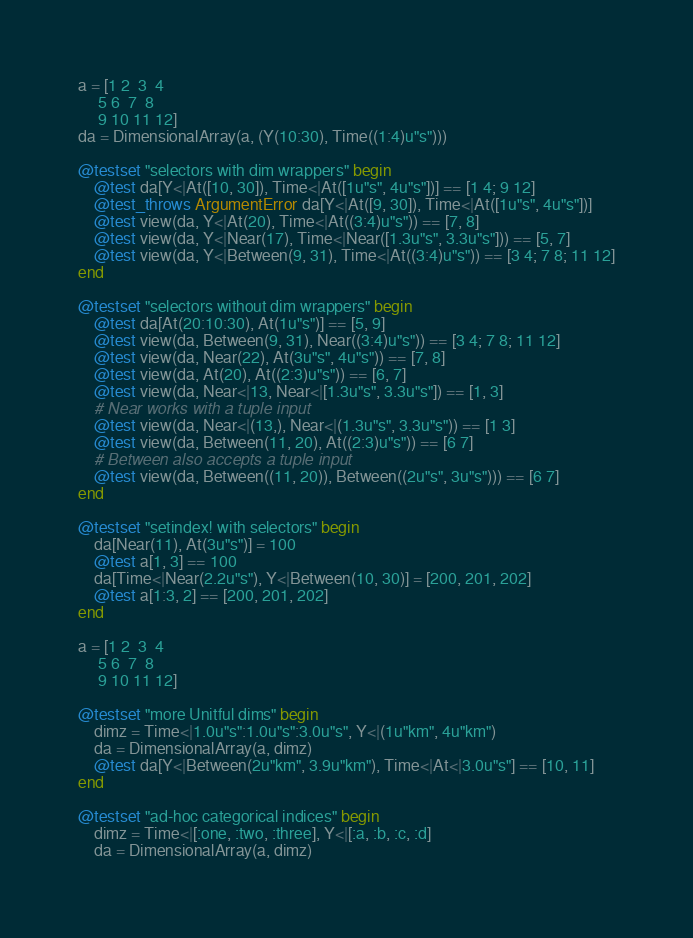Convert code to text. <code><loc_0><loc_0><loc_500><loc_500><_Julia_>a = [1 2  3  4
     5 6  7  8
     9 10 11 12]
da = DimensionalArray(a, (Y(10:30), Time((1:4)u"s")))

@testset "selectors with dim wrappers" begin
    @test da[Y<|At([10, 30]), Time<|At([1u"s", 4u"s"])] == [1 4; 9 12]
    @test_throws ArgumentError da[Y<|At([9, 30]), Time<|At([1u"s", 4u"s"])]
    @test view(da, Y<|At(20), Time<|At((3:4)u"s")) == [7, 8]
    @test view(da, Y<|Near(17), Time<|Near([1.3u"s", 3.3u"s"])) == [5, 7]
    @test view(da, Y<|Between(9, 31), Time<|At((3:4)u"s")) == [3 4; 7 8; 11 12]
end

@testset "selectors without dim wrappers" begin
    @test da[At(20:10:30), At(1u"s")] == [5, 9]
    @test view(da, Between(9, 31), Near((3:4)u"s")) == [3 4; 7 8; 11 12]
    @test view(da, Near(22), At(3u"s", 4u"s")) == [7, 8]
    @test view(da, At(20), At((2:3)u"s")) == [6, 7]
    @test view(da, Near<|13, Near<|[1.3u"s", 3.3u"s"]) == [1, 3]
    # Near works with a tuple input
    @test view(da, Near<|(13,), Near<|(1.3u"s", 3.3u"s")) == [1 3]
    @test view(da, Between(11, 20), At((2:3)u"s")) == [6 7]
    # Between also accepts a tuple input
    @test view(da, Between((11, 20)), Between((2u"s", 3u"s"))) == [6 7]
end

@testset "setindex! with selectors" begin
    da[Near(11), At(3u"s")] = 100
    @test a[1, 3] == 100
    da[Time<|Near(2.2u"s"), Y<|Between(10, 30)] = [200, 201, 202]
    @test a[1:3, 2] == [200, 201, 202] 
end

a = [1 2  3  4
     5 6  7  8
     9 10 11 12]

@testset "more Unitful dims" begin
    dimz = Time<|1.0u"s":1.0u"s":3.0u"s", Y<|(1u"km", 4u"km")
    da = DimensionalArray(a, dimz)
    @test da[Y<|Between(2u"km", 3.9u"km"), Time<|At<|3.0u"s"] == [10, 11]
end

@testset "ad-hoc categorical indices" begin
    dimz = Time<|[:one, :two, :three], Y<|[:a, :b, :c, :d]
    da = DimensionalArray(a, dimz)</code> 